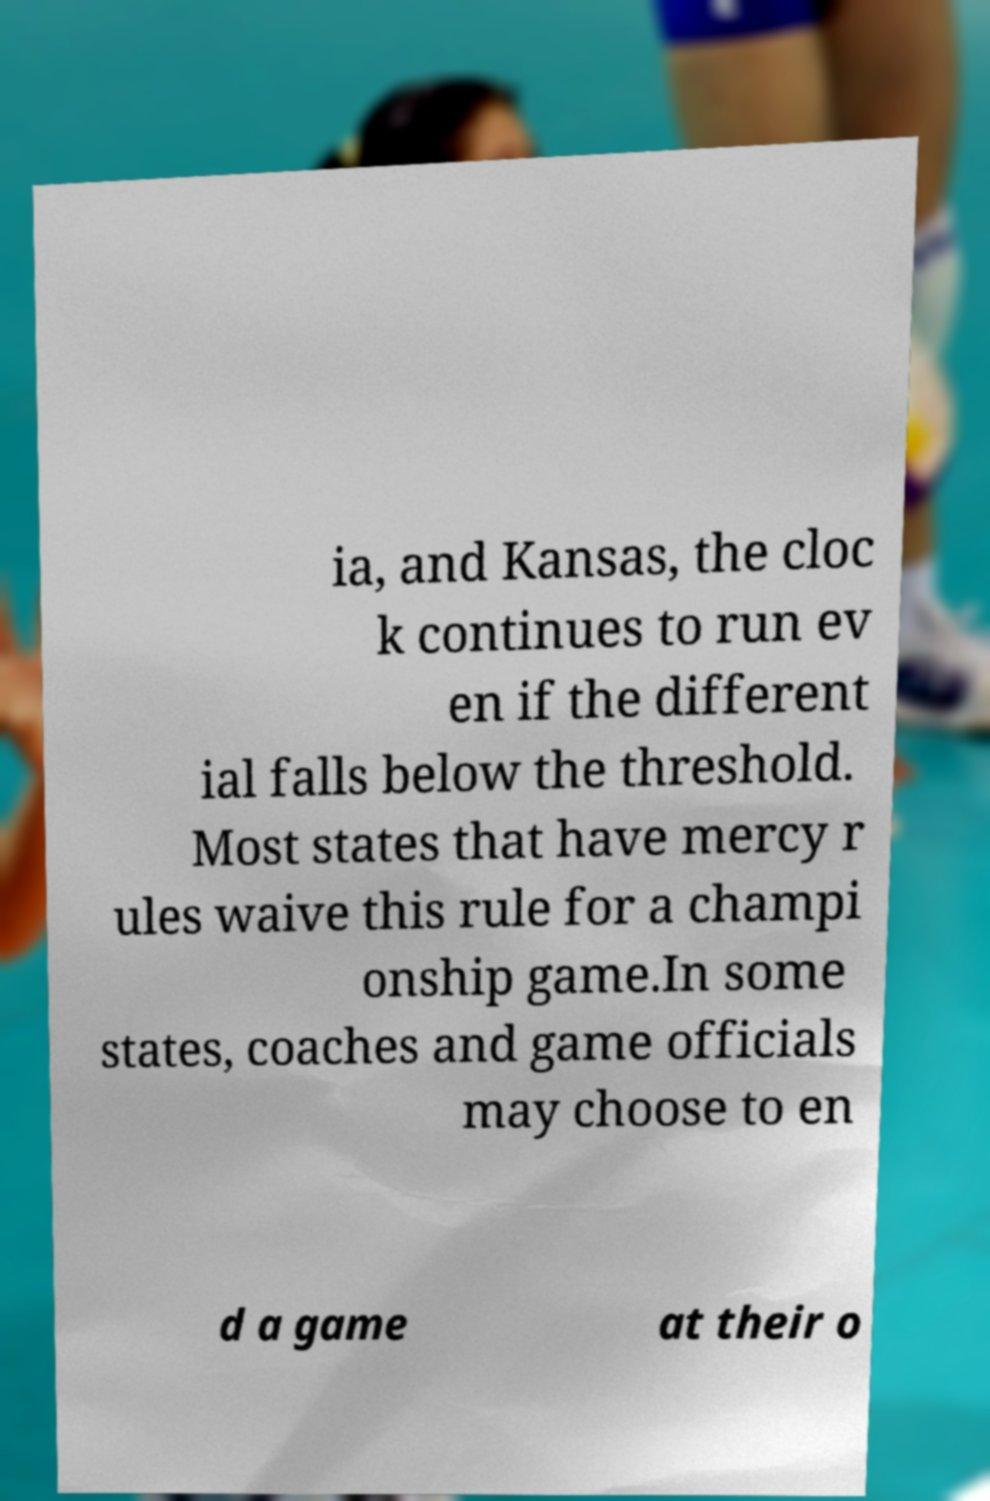Can you read and provide the text displayed in the image?This photo seems to have some interesting text. Can you extract and type it out for me? ia, and Kansas, the cloc k continues to run ev en if the different ial falls below the threshold. Most states that have mercy r ules waive this rule for a champi onship game.In some states, coaches and game officials may choose to en d a game at their o 